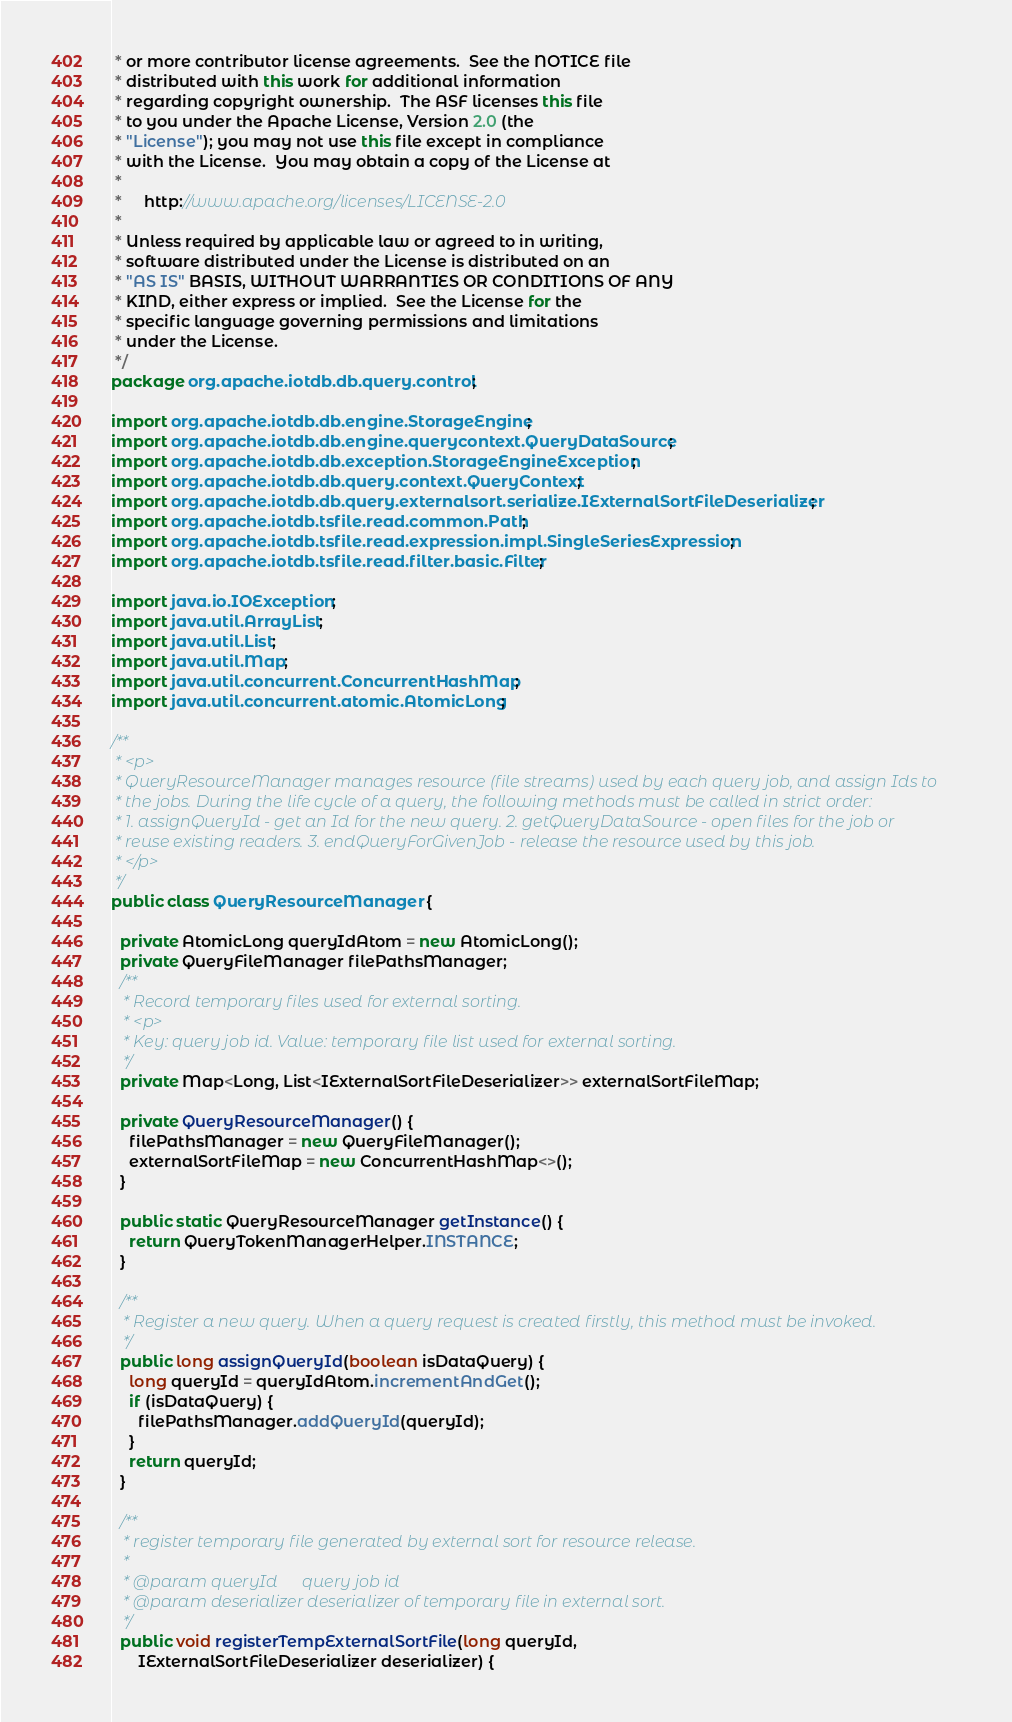<code> <loc_0><loc_0><loc_500><loc_500><_Java_> * or more contributor license agreements.  See the NOTICE file
 * distributed with this work for additional information
 * regarding copyright ownership.  The ASF licenses this file
 * to you under the Apache License, Version 2.0 (the
 * "License"); you may not use this file except in compliance
 * with the License.  You may obtain a copy of the License at
 *
 *     http://www.apache.org/licenses/LICENSE-2.0
 *
 * Unless required by applicable law or agreed to in writing,
 * software distributed under the License is distributed on an
 * "AS IS" BASIS, WITHOUT WARRANTIES OR CONDITIONS OF ANY
 * KIND, either express or implied.  See the License for the
 * specific language governing permissions and limitations
 * under the License.
 */
package org.apache.iotdb.db.query.control;

import org.apache.iotdb.db.engine.StorageEngine;
import org.apache.iotdb.db.engine.querycontext.QueryDataSource;
import org.apache.iotdb.db.exception.StorageEngineException;
import org.apache.iotdb.db.query.context.QueryContext;
import org.apache.iotdb.db.query.externalsort.serialize.IExternalSortFileDeserializer;
import org.apache.iotdb.tsfile.read.common.Path;
import org.apache.iotdb.tsfile.read.expression.impl.SingleSeriesExpression;
import org.apache.iotdb.tsfile.read.filter.basic.Filter;

import java.io.IOException;
import java.util.ArrayList;
import java.util.List;
import java.util.Map;
import java.util.concurrent.ConcurrentHashMap;
import java.util.concurrent.atomic.AtomicLong;

/**
 * <p>
 * QueryResourceManager manages resource (file streams) used by each query job, and assign Ids to
 * the jobs. During the life cycle of a query, the following methods must be called in strict order:
 * 1. assignQueryId - get an Id for the new query. 2. getQueryDataSource - open files for the job or
 * reuse existing readers. 3. endQueryForGivenJob - release the resource used by this job.
 * </p>
 */
public class QueryResourceManager {

  private AtomicLong queryIdAtom = new AtomicLong();
  private QueryFileManager filePathsManager;
  /**
   * Record temporary files used for external sorting.
   * <p>
   * Key: query job id. Value: temporary file list used for external sorting.
   */
  private Map<Long, List<IExternalSortFileDeserializer>> externalSortFileMap;

  private QueryResourceManager() {
    filePathsManager = new QueryFileManager();
    externalSortFileMap = new ConcurrentHashMap<>();
  }

  public static QueryResourceManager getInstance() {
    return QueryTokenManagerHelper.INSTANCE;
  }

  /**
   * Register a new query. When a query request is created firstly, this method must be invoked.
   */
  public long assignQueryId(boolean isDataQuery) {
    long queryId = queryIdAtom.incrementAndGet();
    if (isDataQuery) {
      filePathsManager.addQueryId(queryId);
    }
    return queryId;
  }

  /**
   * register temporary file generated by external sort for resource release.
   *
   * @param queryId      query job id
   * @param deserializer deserializer of temporary file in external sort.
   */
  public void registerTempExternalSortFile(long queryId,
      IExternalSortFileDeserializer deserializer) {</code> 